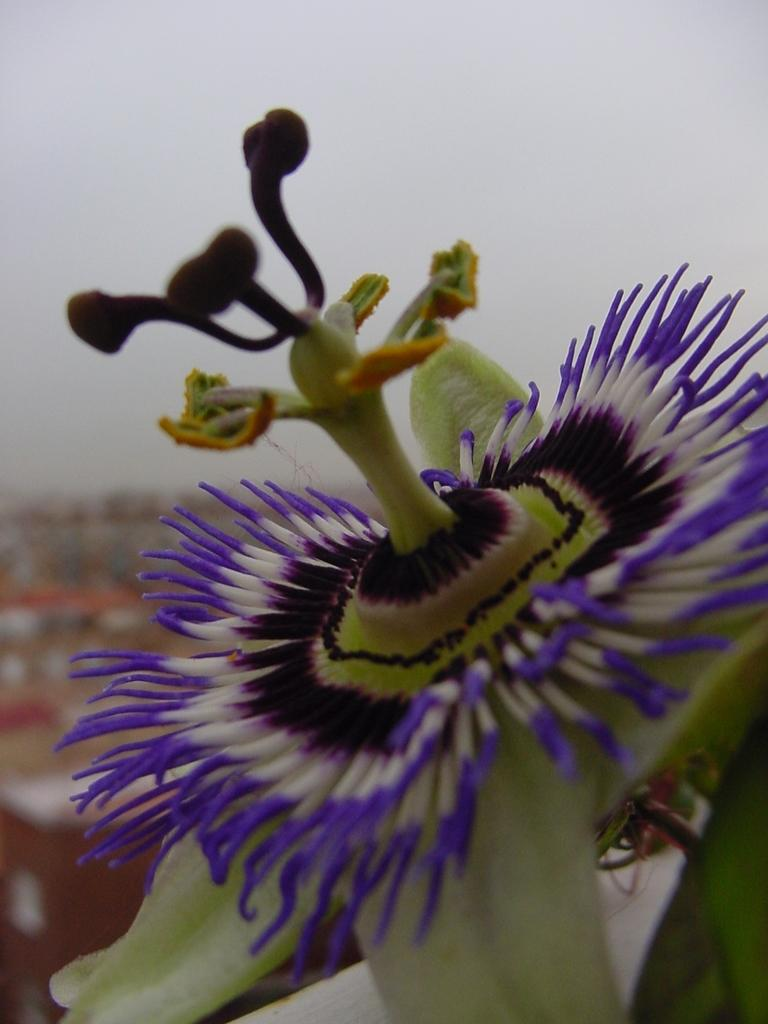What is the main subject of the image? There is a flower in the image. What type of pail is the friend using to water the grandmother's flowers in the image? There is no pail, friend, or grandmother present in the image; it only features a flower. 